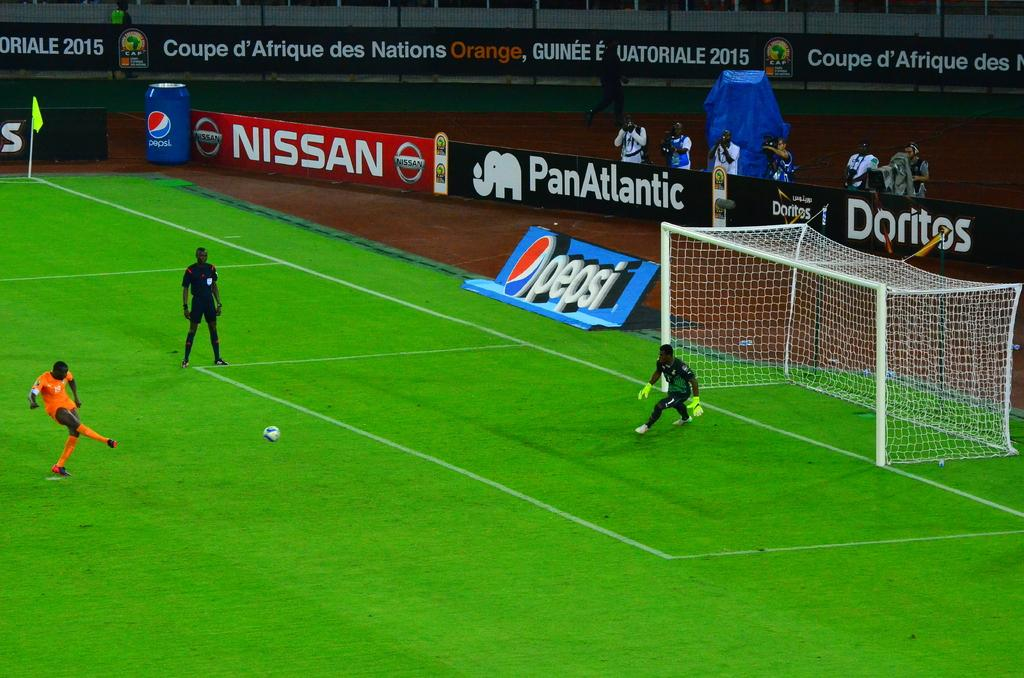<image>
Provide a brief description of the given image. Nissan advertises on the rear left of the field. 